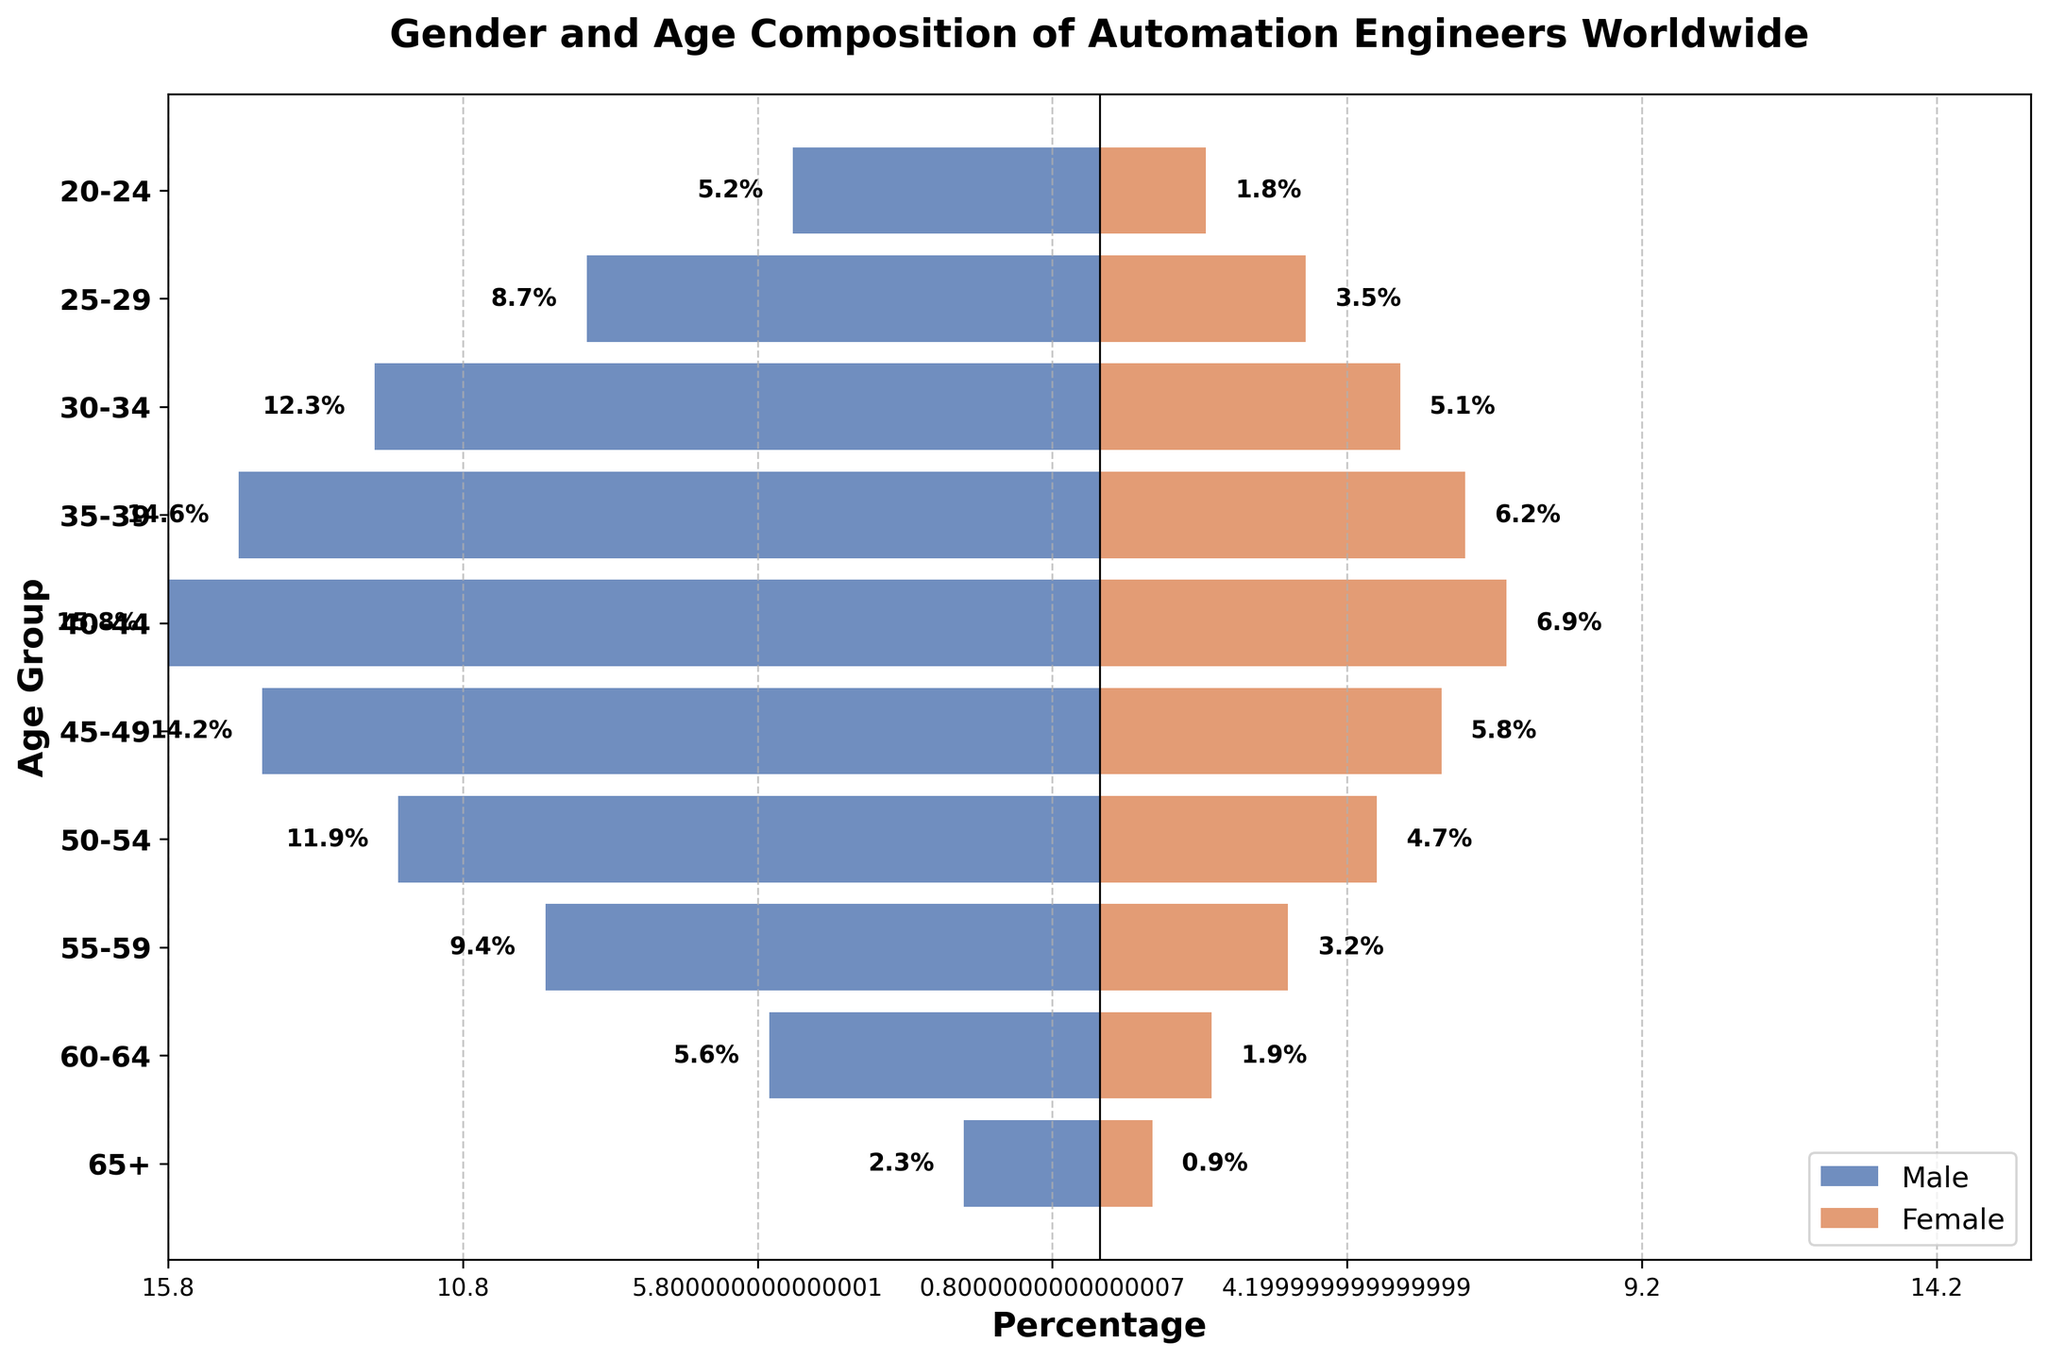What's the title of the figure? The title of the figure is usually displayed at the top-center of the plot. This figure’s title specifically conveys the overall subject and context of the visual representation.
Answer: Gender and Age Composition of Automation Engineers Worldwide What is the male percentage in the 40-44 age group? To find this percentage, locate the 40-44 age group on the y-axis. Then, check the corresponding horizontal bar for the male group, noted in the legend as the blue bar.
Answer: 15.8% Which age group has the highest percentage of female engineers? Compare the lengths of the red (female) bars across all age groups to find the longest one. The tallest bar represents the age group with the highest percentage.
Answer: 40-44 What is the combined percentage for males and females in the 35-39 age group? To get the combined percentage, identify the percentages for males and females in the 35-39 age group and sum them. Identify from the blue and red bars.
Answer: 14.6% (male) + 6.2% (female) = 20.8% Which age group's bar lengths are equal when comparing males to females? Search for an age group where the lengths of the blue and red bars are visually or exactly equal.
Answer: None How much larger is the percentage of males compared to females in the 50-54 age group? Determine the values for both males and females in the 50-54 age group. Calculate the difference between the two values.
Answer: 11.9% (male) - 4.7% (female) = 7.2% In which age groups do females constitute more than 5%? Examine each red bar (female percentage) and identify age groups where the percentage is greater than 5%.
Answer: 30-34, 35-39, 40-44 What age group has the smallest percentage of automation engineers overall? Find the smallest percentages of both males and females combined across all age groups.
Answer: 65+ For the age group 25-29, what is the female percentage as a fraction of the male percentage? Obtain the percentages for males and females in the 25-29 age group. Then, divide the female percentage by the male percentage and simplify the result to a fraction.
Answer: 3.5% / 8.7% ≈ 0.402, or roughly 40/100, simplified to 2/5 Which age group shows a sharp decline in the percentage for both males and females compared to the previous group? Trace the pattern of percentages through the age groups and identify where there's a significant drop for both genders.
Answer: 55-59 group compared to 50-54 